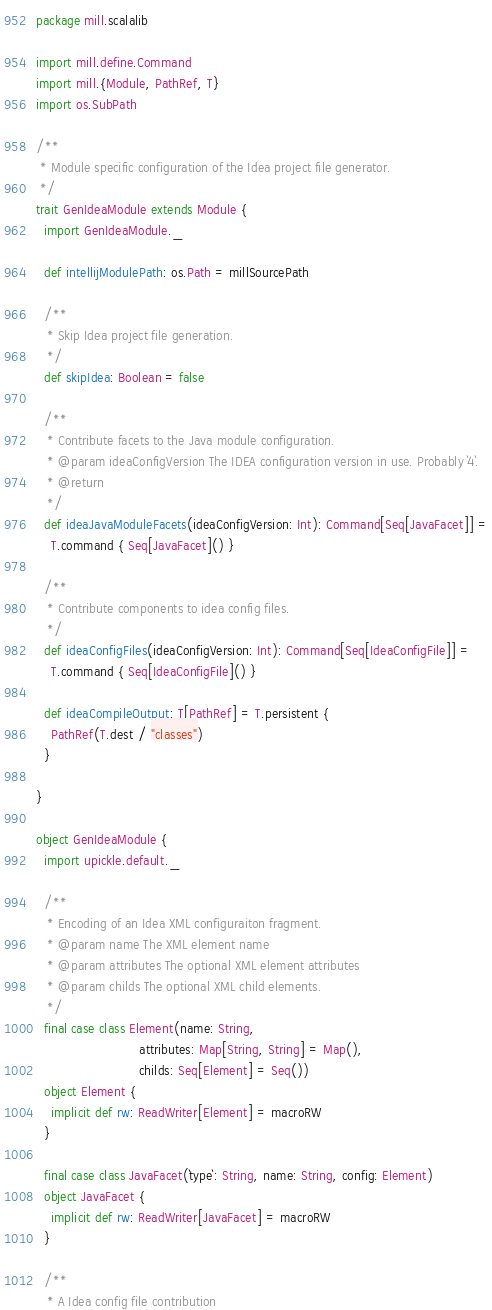Convert code to text. <code><loc_0><loc_0><loc_500><loc_500><_Scala_>package mill.scalalib

import mill.define.Command
import mill.{Module, PathRef, T}
import os.SubPath

/**
 * Module specific configuration of the Idea project file generator.
 */
trait GenIdeaModule extends Module {
  import GenIdeaModule._

  def intellijModulePath: os.Path = millSourcePath

  /**
   * Skip Idea project file generation.
   */
  def skipIdea: Boolean = false

  /**
   * Contribute facets to the Java module configuration.
   * @param ideaConfigVersion The IDEA configuration version in use. Probably `4`.
   * @return
   */
  def ideaJavaModuleFacets(ideaConfigVersion: Int): Command[Seq[JavaFacet]] =
    T.command { Seq[JavaFacet]() }

  /**
   * Contribute components to idea config files.
   */
  def ideaConfigFiles(ideaConfigVersion: Int): Command[Seq[IdeaConfigFile]] =
    T.command { Seq[IdeaConfigFile]() }

  def ideaCompileOutput: T[PathRef] = T.persistent {
    PathRef(T.dest / "classes")
  }

}

object GenIdeaModule {
  import upickle.default._

  /**
   * Encoding of an Idea XML configuraiton fragment.
   * @param name The XML element name
   * @param attributes The optional XML element attributes
   * @param childs The optional XML child elements.
   */
  final case class Element(name: String,
                           attributes: Map[String, String] = Map(),
                           childs: Seq[Element] = Seq())
  object Element {
    implicit def rw: ReadWriter[Element] = macroRW
  }

  final case class JavaFacet(`type`: String, name: String, config: Element)
  object JavaFacet {
    implicit def rw: ReadWriter[JavaFacet] = macroRW
  }

  /**
   * A Idea config file contribution</code> 